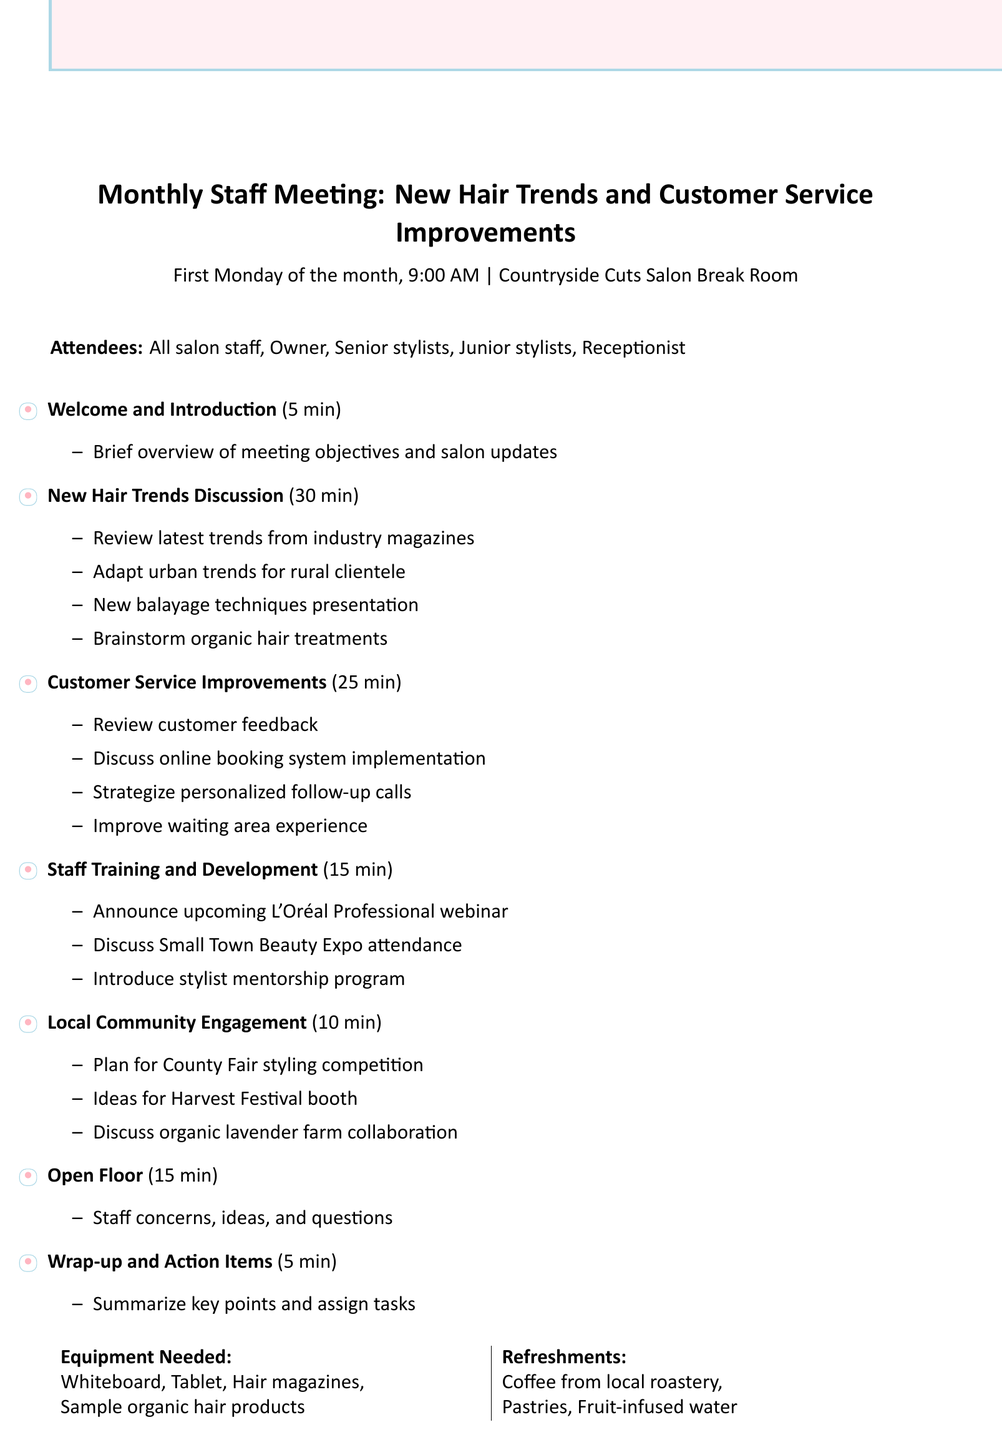What is the meeting title? The meeting title is the main heading of the document, which specifies the focus of the meeting.
Answer: Monthly Staff Meeting: New Hair Trends and Customer Service Improvements When is the meeting scheduled? The date and time are noted in the document to inform attendees of when to join.
Answer: First Monday of the month, 9:00 AM Where will the meeting take place? The location of the meeting is mentioned to ensure all attendees know where to go.
Answer: Countryside Cuts Salon Break Room Who will attend the meeting? The list of attendees gives an idea of who will be present to discuss the agenda items.
Answer: All salon staff, Owner, Senior stylists, Junior stylists, Receptionist How long is the New Hair Trends Discussion scheduled for? Each agenda item includes a duration, which helps plan how much time to allocate for each topic.
Answer: 30 minutes What is one of the topics of discussion under Customer Service Improvements? This part of the document focuses on improvements in client services and how they can enhance customer experience.
Answer: Review of customer feedback from suggestion box What will be discussed under Staff Training and Development? The section outlines upcoming opportunities for professional development for the staff.
Answer: Upcoming webinar on latest coloring techniques by L'Oréal Professional What is one idea for Local Community Engagement? This section suggests ways the salon can connect with the local community and increase visibility.
Answer: Participate in upcoming County Fair hair styling competition What are the refreshments provided during the meeting? The document lists refreshments to be offered, enhancing the meeting experience for attendees.
Answer: Coffee from local roastery, Pastries from Main Street Bakery, Fruit-infused water 